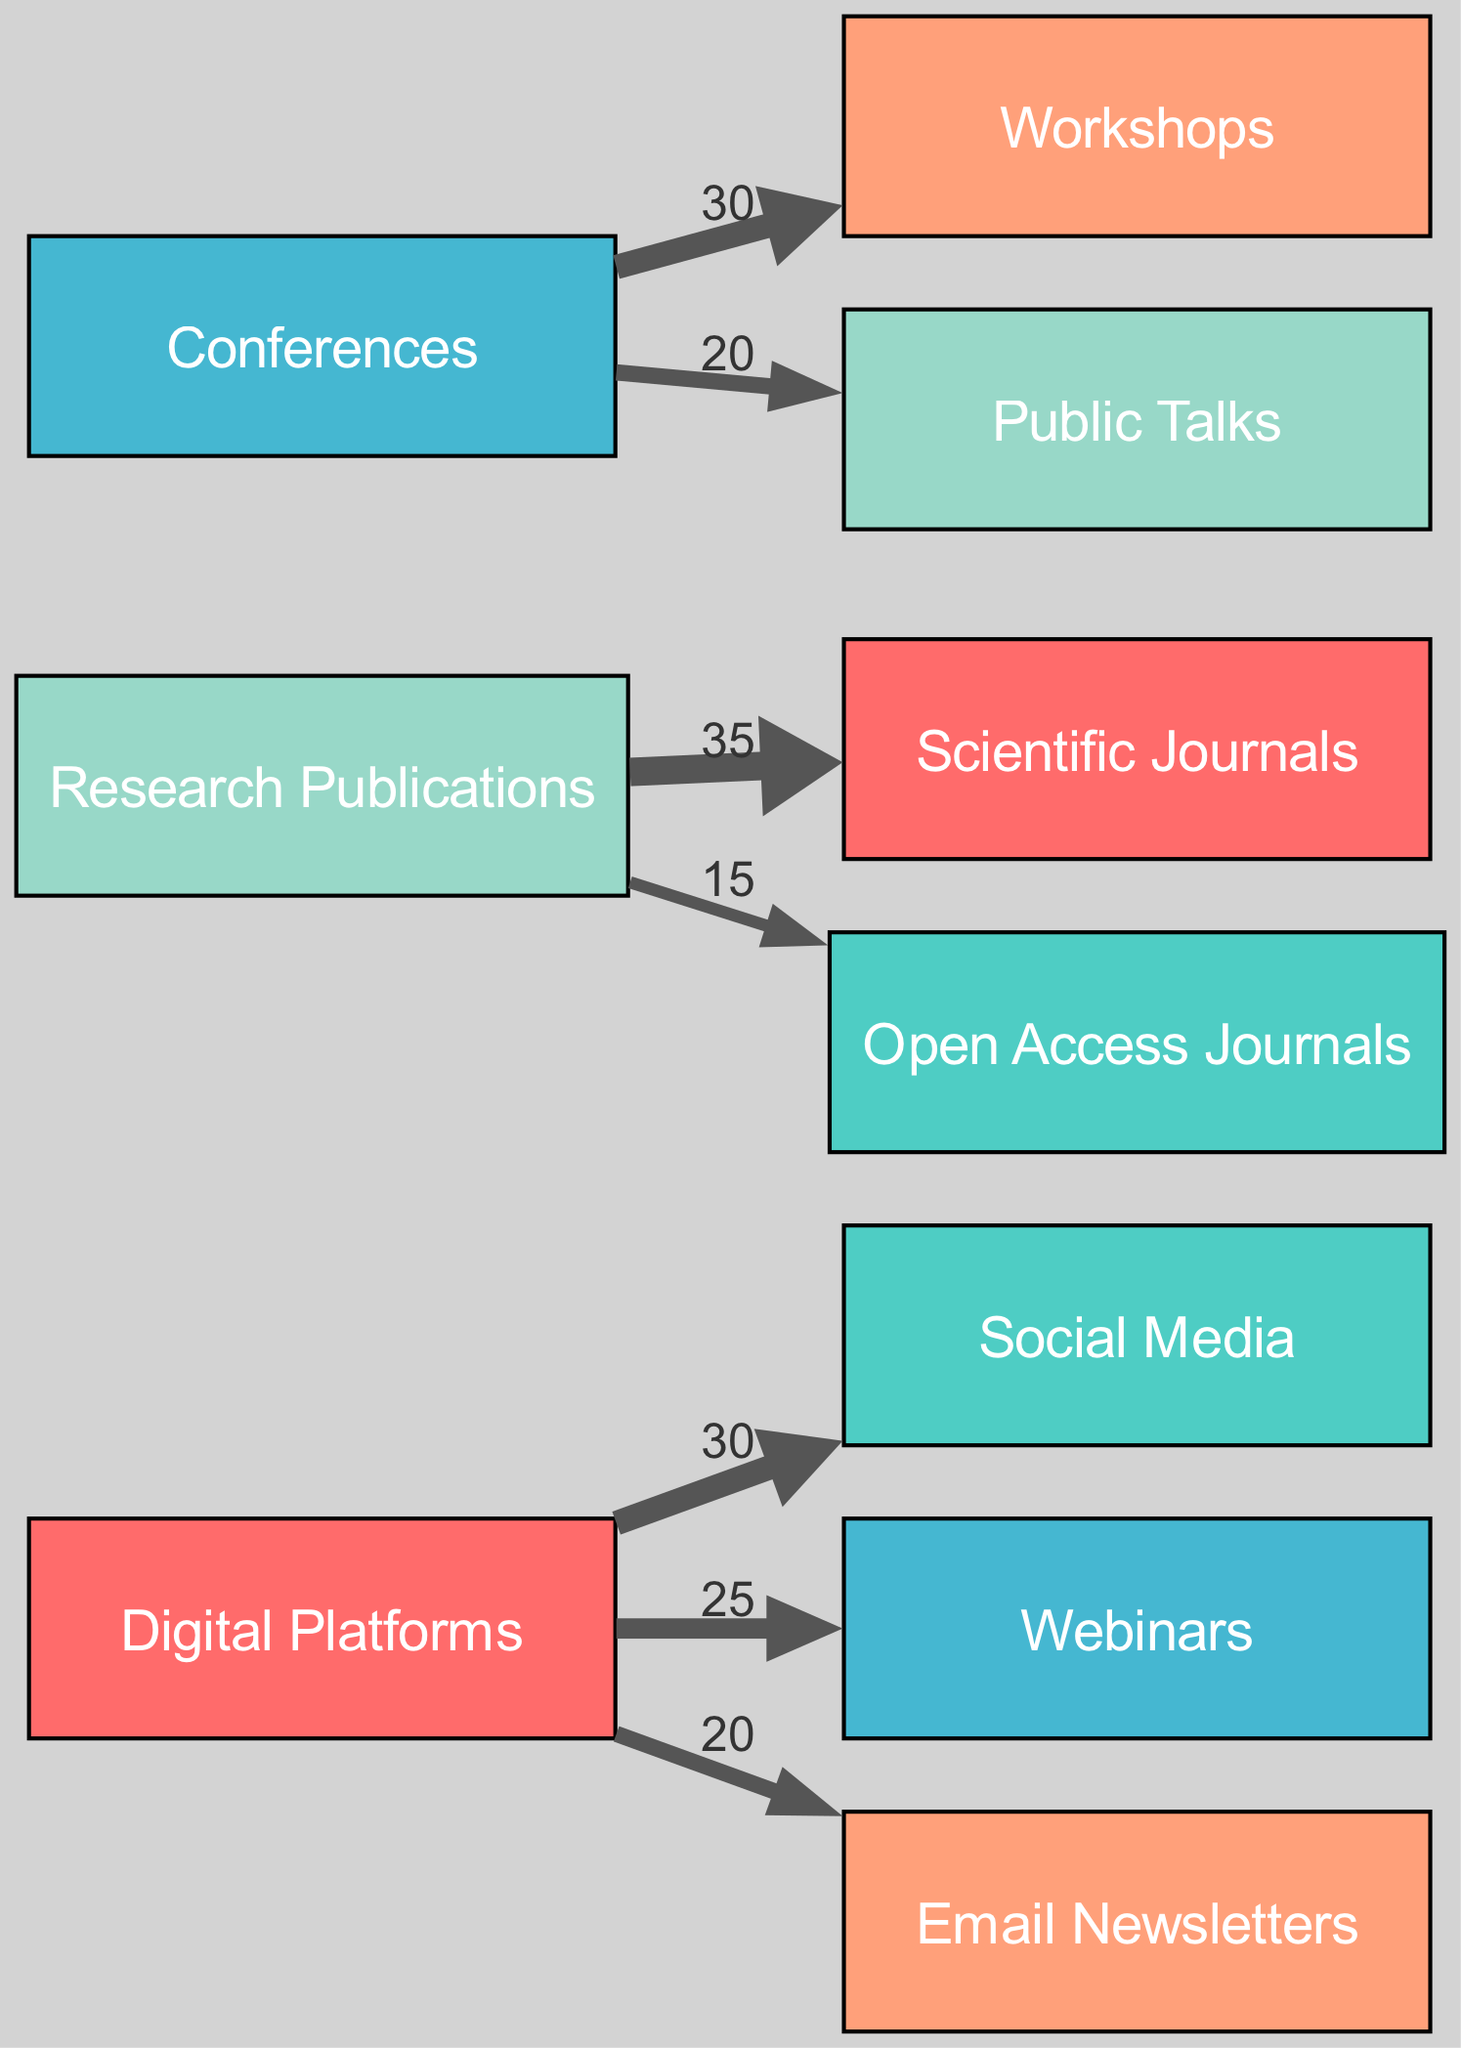What is the total number of nodes in the diagram? There are ten unique nodes representing the different research dissemination methods utilized by food scientists. Counting each unique node in the provided dataset confirms there are ten nodes present: Digital Platforms, Social Media, Webinars, Email Newsletters, Research Publications, Scientific Journals, Open Access Journals, Conferences, Workshops, and Public Talks.
Answer: 10 What is the flow value from Digital Platforms to Social Media? The link connecting Digital Platforms to Social Media has a value labeled '30', which represents the flow of research dissemination from Digital Platforms specifically to Social Media.
Answer: 30 Which method has the highest flow value associated with it? The highest flow value in the diagram is attributed to the link from Digital Platforms to Social Media, which has a value of 30. This indicates that Social Media is the primary digital platform utilized for dissemination.
Answer: Social Media How many research dissemination methods fall under Research Publications? There are two methods categorized under Research Publications: Scientific Journals and Open Access Journals, as shown by the outgoing links from Research Publications to these two nodes.
Answer: 2 What is the total value of flows from Conferences? The total flow value from Conferences is calculated by adding the flow values associated with its outgoing links: Workshops (30) and Public Talks (20), resulting in a total of 50.
Answer: 50 Which digital platform has a flow value closest to Webinars? Webinars has a flow value of 25, and the closest flow value is Email Newsletters, which has a flow value of 20. This comparison shows that Email Newsletters is the digital platform nearest in terms of flow value to Webinars.
Answer: Email Newsletters What is the combined flow value for Scientific Journals and Open Access Journals? The combined flow value from Research Publications to both Scientific Journals (35) and Open Access Journals (15) totals 50 when added together. Thus, the total value is computed by: 35 + 15 = 50.
Answer: 50 How many total flows are represented in the diagram? The diagram has six distinct flows represented by links: from Digital Platforms to Social Media, Webinars, Email Newsletters; from Research Publications to Scientific Journals, Open Access Journals; and from Conferences to Workshops, Public Talks. Summing these counts results in a total of six flows.
Answer: 6 Which method has a greater flow: Workshops or Public Talks? Comparing both methods, Workshops has a flow value of 30 while Public Talks has a value of 20. The higher flow indicates that Workshops is the more common method for dissemination in relation to Public Talks.
Answer: Workshops 